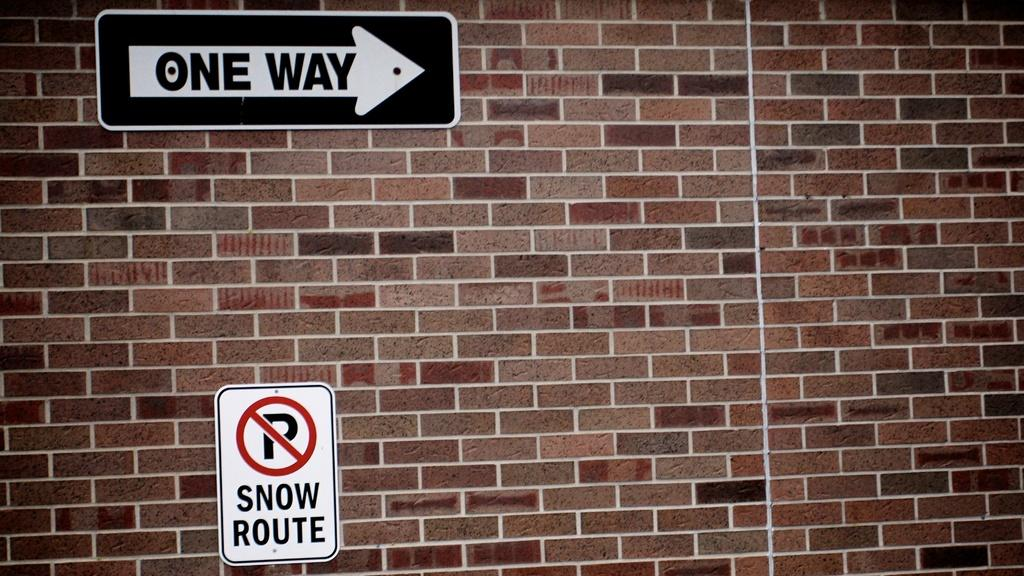Provide a one-sentence caption for the provided image. Signs on a brick wall show One Way and No Parking Snow Route. 